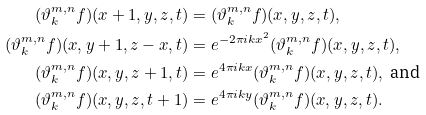<formula> <loc_0><loc_0><loc_500><loc_500>( \vartheta _ { k } ^ { m , n } f ) ( x + 1 , y , z , t ) & = ( \vartheta _ { k } ^ { m , n } f ) ( x , y , z , t ) , \\ ( \vartheta _ { k } ^ { m , n } f ) ( x , y + 1 , z - x , t ) & = e ^ { - 2 \pi i k x ^ { 2 } } ( \vartheta _ { k } ^ { m , n } f ) ( x , y , z , t ) , \\ ( \vartheta _ { k } ^ { m , n } f ) ( x , y , z + 1 , t ) & = e ^ { 4 \pi i k x } ( \vartheta _ { k } ^ { m , n } f ) ( x , y , z , t ) , \text { and} \\ ( \vartheta _ { k } ^ { m , n } f ) ( x , y , z , t + 1 ) & = e ^ { 4 \pi i k y } ( \vartheta _ { k } ^ { m , n } f ) ( x , y , z , t ) .</formula> 